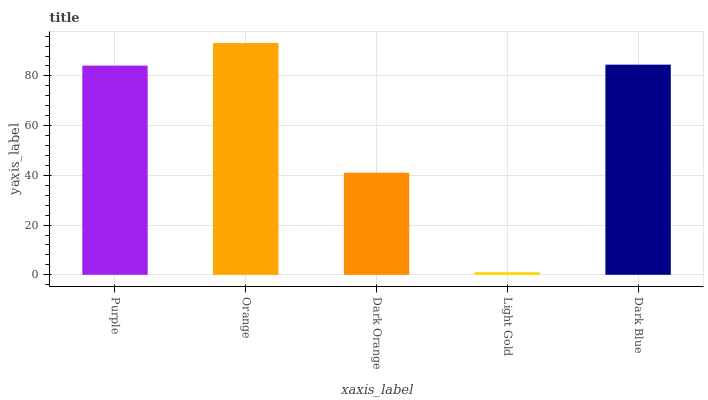Is Dark Orange the minimum?
Answer yes or no. No. Is Dark Orange the maximum?
Answer yes or no. No. Is Orange greater than Dark Orange?
Answer yes or no. Yes. Is Dark Orange less than Orange?
Answer yes or no. Yes. Is Dark Orange greater than Orange?
Answer yes or no. No. Is Orange less than Dark Orange?
Answer yes or no. No. Is Purple the high median?
Answer yes or no. Yes. Is Purple the low median?
Answer yes or no. Yes. Is Dark Orange the high median?
Answer yes or no. No. Is Orange the low median?
Answer yes or no. No. 